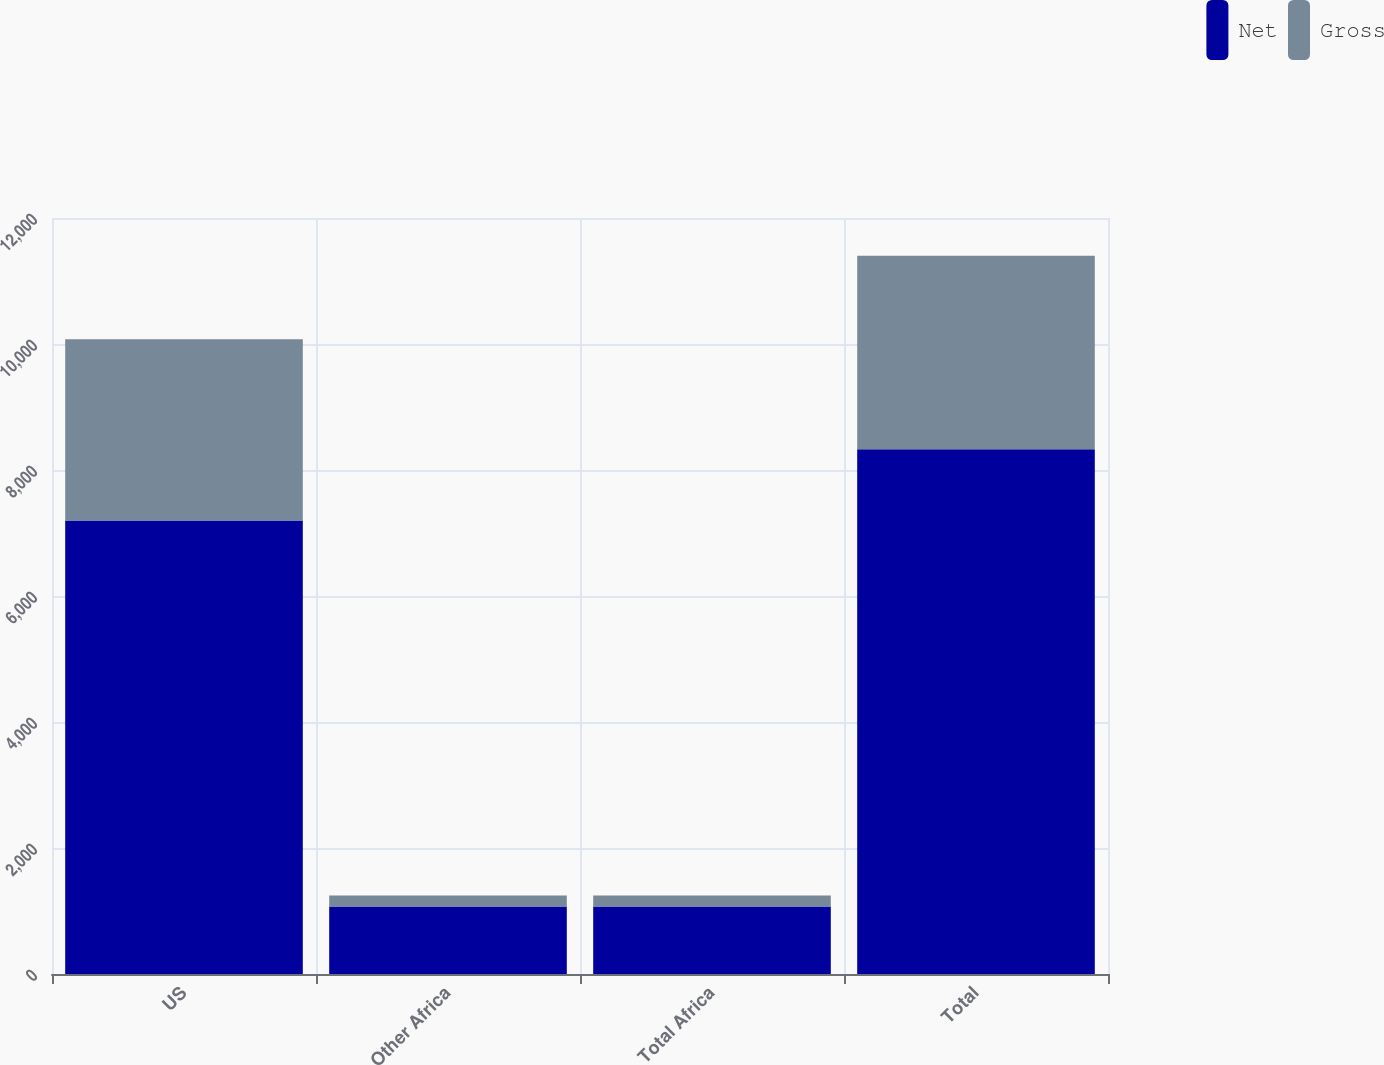Convert chart to OTSL. <chart><loc_0><loc_0><loc_500><loc_500><stacked_bar_chart><ecel><fcel>US<fcel>Other Africa<fcel>Total Africa<fcel>Total<nl><fcel>Net<fcel>7198<fcel>1071<fcel>1071<fcel>8328<nl><fcel>Gross<fcel>2878<fcel>175<fcel>175<fcel>3074<nl></chart> 